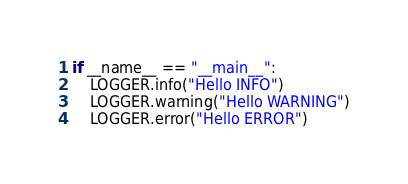Convert code to text. <code><loc_0><loc_0><loc_500><loc_500><_Python_>if __name__ == "__main__":
    LOGGER.info("Hello INFO")
    LOGGER.warning("Hello WARNING")
    LOGGER.error("Hello ERROR")
</code> 